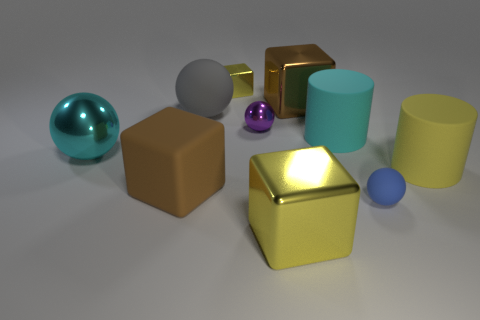There is a brown thing that is the same material as the tiny purple thing; what is its shape?
Your answer should be compact. Cube. How many small things are matte cubes or cyan cubes?
Provide a short and direct response. 0. Are there any small blue matte objects on the left side of the rubber ball that is right of the purple thing?
Offer a terse response. No. Are any yellow cylinders visible?
Offer a very short reply. Yes. There is a metallic thing in front of the large thing that is right of the tiny matte object; what color is it?
Give a very brief answer. Yellow. What material is the other large object that is the same shape as the yellow matte thing?
Your answer should be compact. Rubber. What number of cyan matte things are the same size as the purple metallic thing?
Make the answer very short. 0. There is a yellow object that is made of the same material as the blue thing; what is its size?
Ensure brevity in your answer.  Large. How many tiny purple metallic objects are the same shape as the gray thing?
Offer a very short reply. 1. What number of big cyan rubber cylinders are there?
Your answer should be compact. 1. 